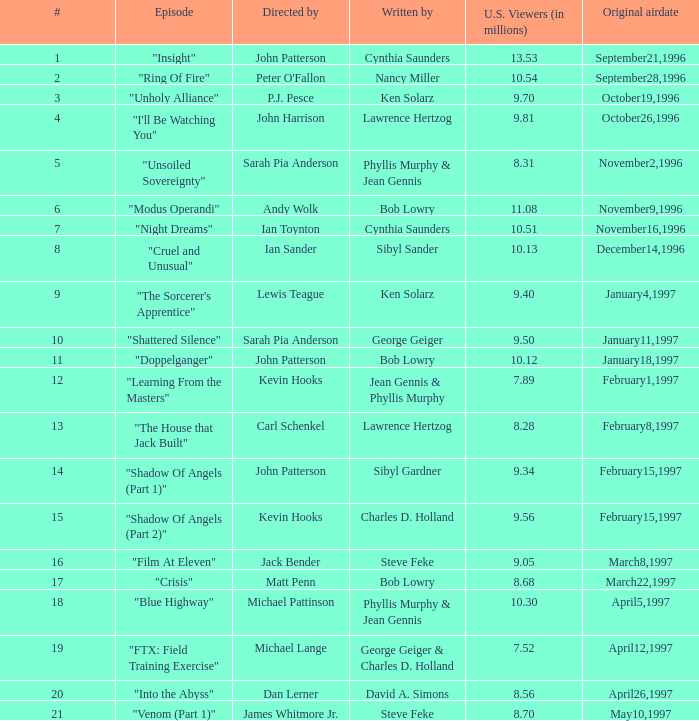Who wrote the episode with 7.52 million US viewers? George Geiger & Charles D. Holland. 